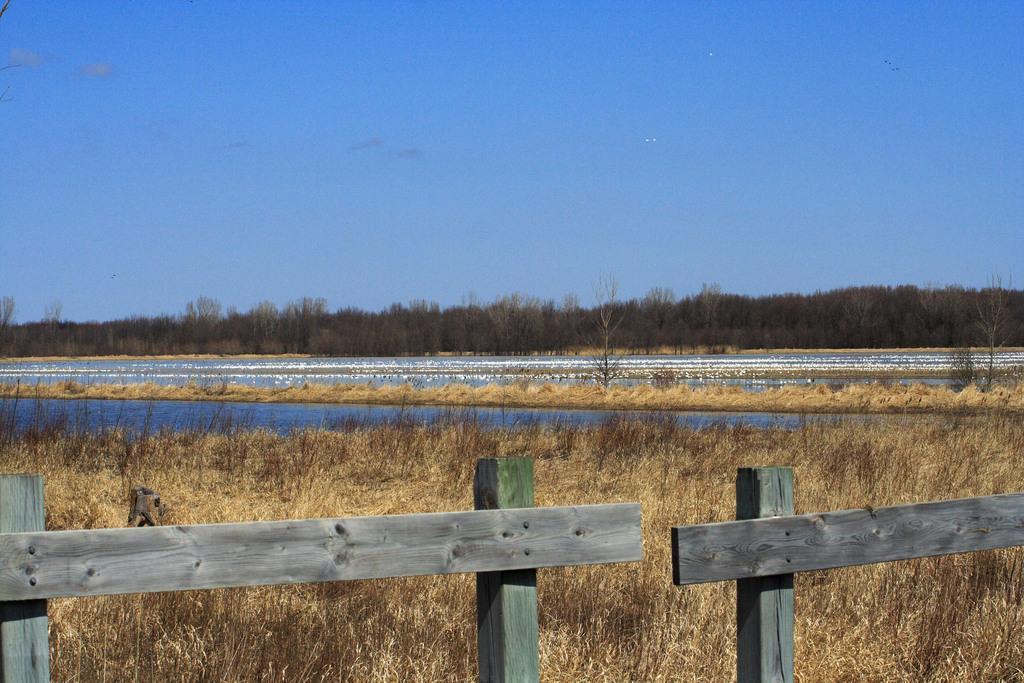Describe this image in one or two sentences. In this image we can see wooden fence, water, dried lawn straw, trees and sky. 